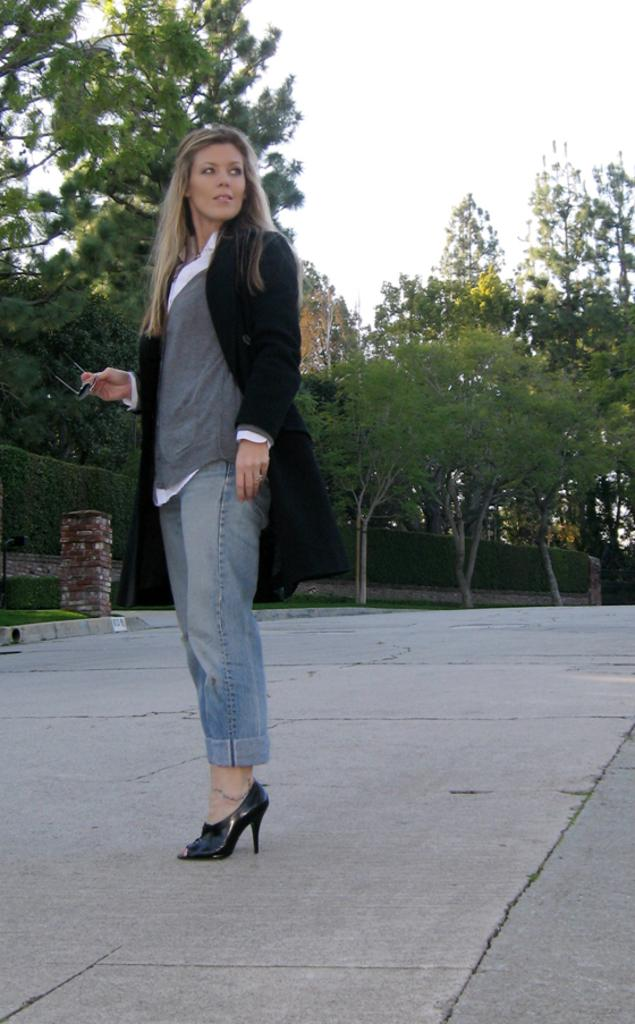Who is the main subject in the image? There is a lady in the image. What is the lady doing in the image? The lady is standing on the floor. What is the lady holding in her hand? The lady is holding spectacles in her hand. What can be seen in the background of the image? There are bushes, trees, and the sky visible in the background of the image. What type of metal structure can be seen behind the lady in the image? There is no metal structure visible behind the lady in the image. 